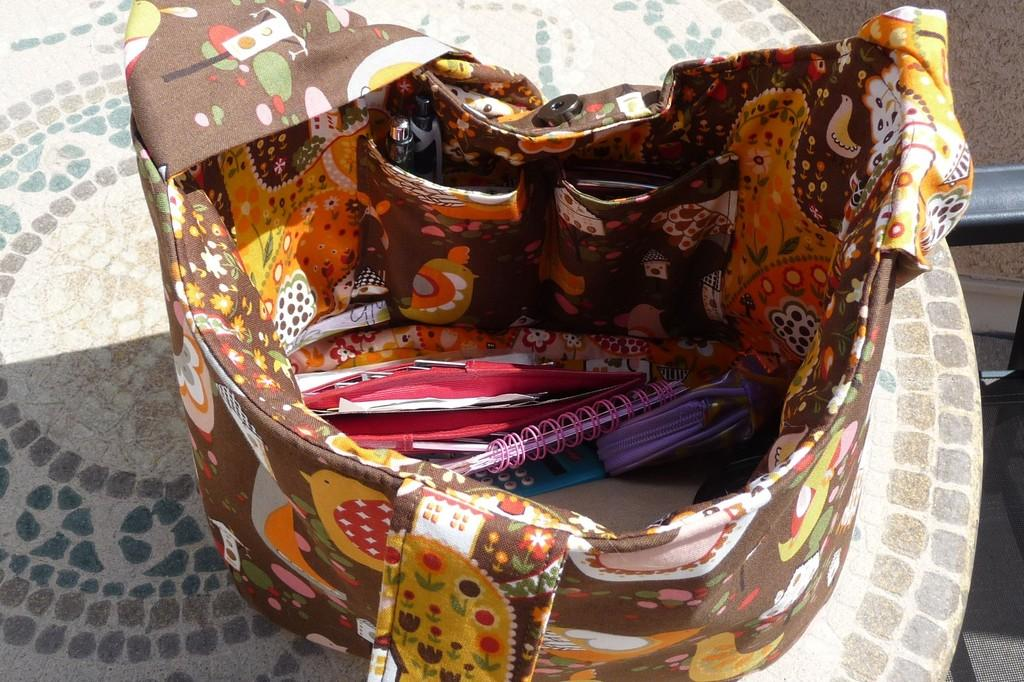What object is visible in the image? There is a handbag in the image. What is inside the handbag? The handbag contains books, pens, and additional items (such as "etc."). Can you describe the contents of the handbag in more detail? The handbag contains books and pens, as well as other items that are not specified. What type of cup is being used to cook in the image? There is no cup or cooking activity present in the image; it features a handbag with books, pens, and additional items. 